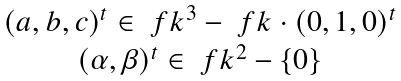<formula> <loc_0><loc_0><loc_500><loc_500>\begin{matrix} ( a , b , c ) ^ { t } \in \ f k ^ { 3 } - \ f k \cdot ( 0 , 1 , 0 ) ^ { t } \\ ( \alpha , \beta ) ^ { t } \in \ f k ^ { 2 } - \{ 0 \} \end{matrix}</formula> 